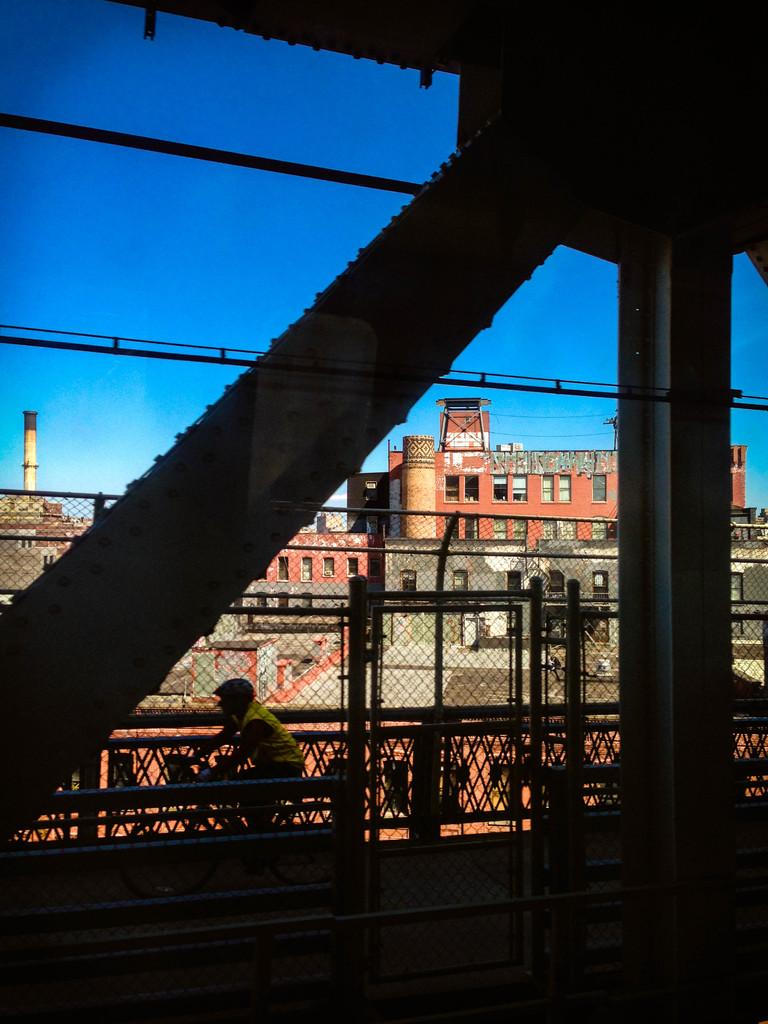What is one of the main structures in the image? There is a pillar in the image. What type of material is present in the image? There is mesh and rods in the image. What type of man-made structures can be seen in the image? There are buildings in the image. What other objects can be seen in the image? There are wires in the image. What activity is a person engaged in within the image? A person is riding a bicycle in the image. What can be seen in the background of the image? The sky is visible in the background of the image. Can you tell me how many pins are holding the bicycle in the image? There are no pins present in the image; the person is riding a bicycle without any visible pins. What type of pet is visible in the image? There is no pet present in the image. 